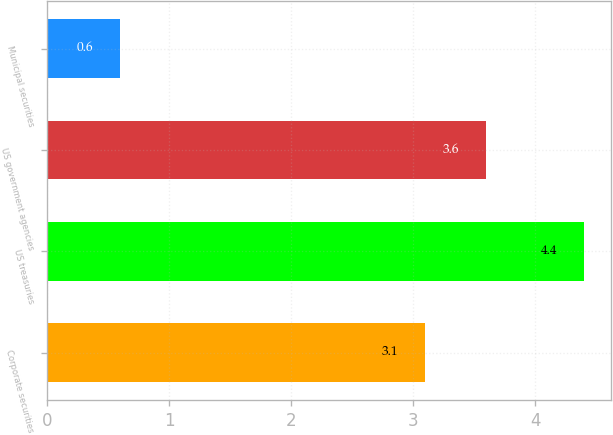Convert chart. <chart><loc_0><loc_0><loc_500><loc_500><bar_chart><fcel>Corporate securities<fcel>US treasuries<fcel>US government agencies<fcel>Municipal securities<nl><fcel>3.1<fcel>4.4<fcel>3.6<fcel>0.6<nl></chart> 